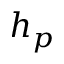<formula> <loc_0><loc_0><loc_500><loc_500>h _ { p }</formula> 